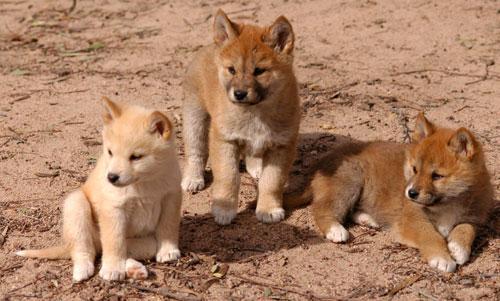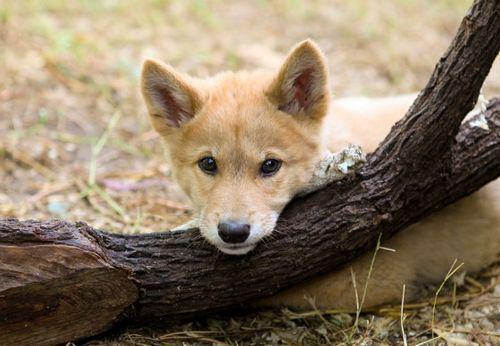The first image is the image on the left, the second image is the image on the right. Assess this claim about the two images: "There are more canines in the left image than the right.". Correct or not? Answer yes or no. Yes. 